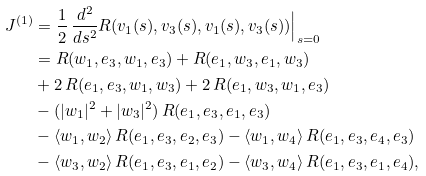Convert formula to latex. <formula><loc_0><loc_0><loc_500><loc_500>J ^ { ( 1 ) } & = \frac { 1 } { 2 } \, \frac { d ^ { 2 } } { d s ^ { 2 } } R ( v _ { 1 } ( s ) , v _ { 3 } ( s ) , v _ { 1 } ( s ) , v _ { 3 } ( s ) ) \Big | _ { s = 0 } \\ & = R ( w _ { 1 } , e _ { 3 } , w _ { 1 } , e _ { 3 } ) + R ( e _ { 1 } , w _ { 3 } , e _ { 1 } , w _ { 3 } ) \\ & + 2 \, R ( e _ { 1 } , e _ { 3 } , w _ { 1 } , w _ { 3 } ) + 2 \, R ( e _ { 1 } , w _ { 3 } , w _ { 1 } , e _ { 3 } ) \\ & - ( | w _ { 1 } | ^ { 2 } + | w _ { 3 } | ^ { 2 } ) \, R ( e _ { 1 } , e _ { 3 } , e _ { 1 } , e _ { 3 } ) \\ & - \langle w _ { 1 } , w _ { 2 } \rangle \, R ( e _ { 1 } , e _ { 3 } , e _ { 2 } , e _ { 3 } ) - \langle w _ { 1 } , w _ { 4 } \rangle \, R ( e _ { 1 } , e _ { 3 } , e _ { 4 } , e _ { 3 } ) \\ & - \langle w _ { 3 } , w _ { 2 } \rangle \, R ( e _ { 1 } , e _ { 3 } , e _ { 1 } , e _ { 2 } ) - \langle w _ { 3 } , w _ { 4 } \rangle \, R ( e _ { 1 } , e _ { 3 } , e _ { 1 } , e _ { 4 } ) ,</formula> 